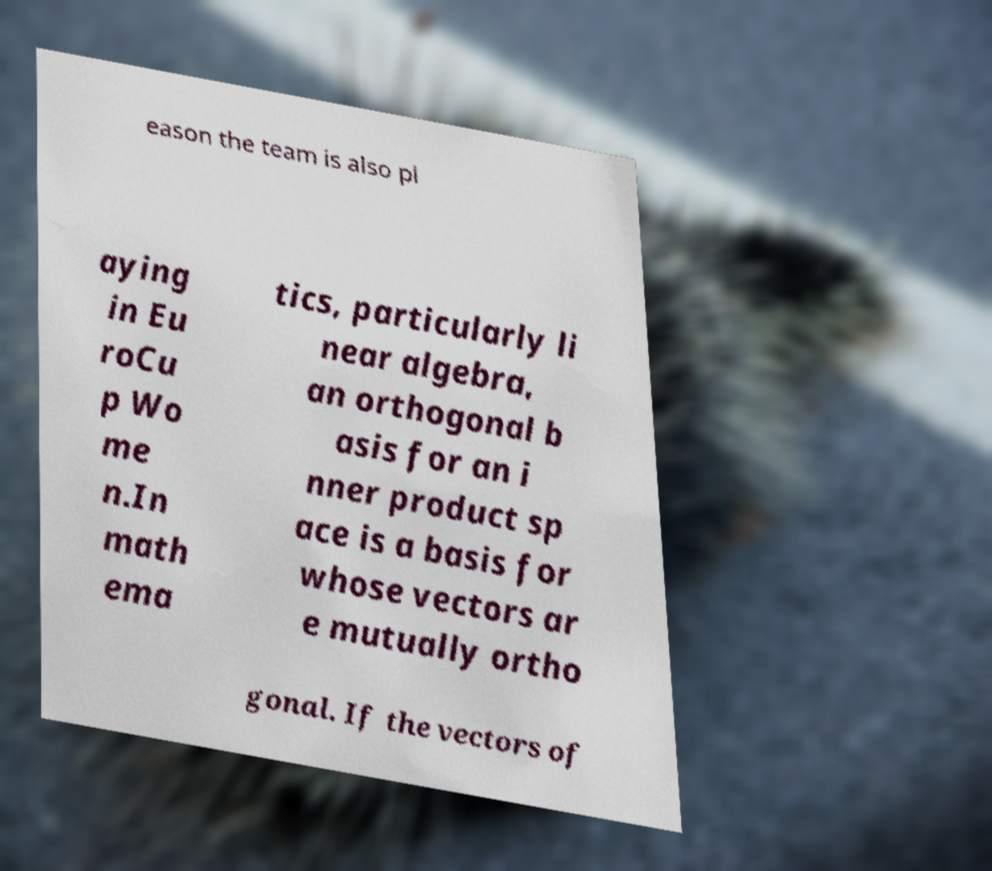Please identify and transcribe the text found in this image. eason the team is also pl aying in Eu roCu p Wo me n.In math ema tics, particularly li near algebra, an orthogonal b asis for an i nner product sp ace is a basis for whose vectors ar e mutually ortho gonal. If the vectors of 